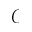<formula> <loc_0><loc_0><loc_500><loc_500>\ m a t h s c r { C }</formula> 